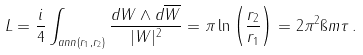Convert formula to latex. <formula><loc_0><loc_0><loc_500><loc_500>L = \frac { i } { 4 } \int _ { a n n ( r _ { 1 } , r _ { 2 } ) } \frac { d W \wedge d \overline { W } } { | W | ^ { 2 } } = \pi \ln \left ( \frac { r _ { 2 } } { r _ { 1 } } \right ) = 2 \pi ^ { 2 } \i m \tau \, .</formula> 